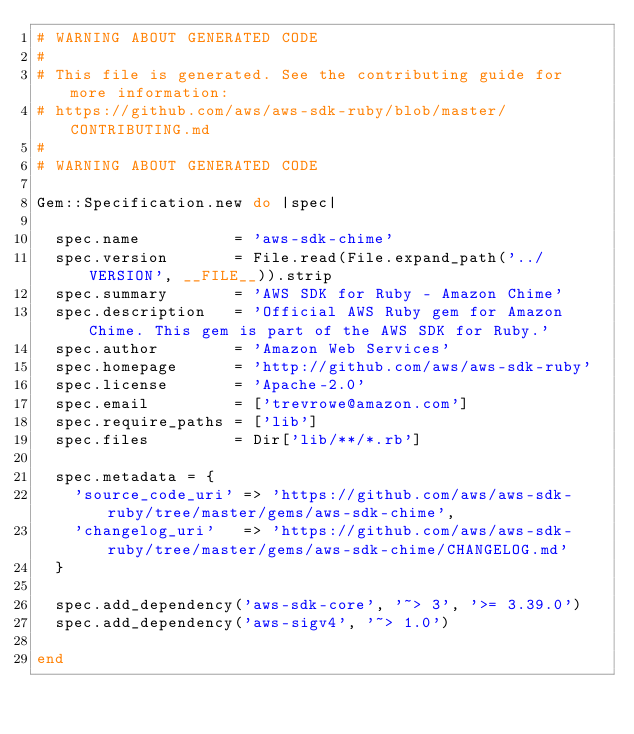Convert code to text. <code><loc_0><loc_0><loc_500><loc_500><_Ruby_># WARNING ABOUT GENERATED CODE
#
# This file is generated. See the contributing guide for more information:
# https://github.com/aws/aws-sdk-ruby/blob/master/CONTRIBUTING.md
#
# WARNING ABOUT GENERATED CODE

Gem::Specification.new do |spec|

  spec.name          = 'aws-sdk-chime'
  spec.version       = File.read(File.expand_path('../VERSION', __FILE__)).strip
  spec.summary       = 'AWS SDK for Ruby - Amazon Chime'
  spec.description   = 'Official AWS Ruby gem for Amazon Chime. This gem is part of the AWS SDK for Ruby.'
  spec.author        = 'Amazon Web Services'
  spec.homepage      = 'http://github.com/aws/aws-sdk-ruby'
  spec.license       = 'Apache-2.0'
  spec.email         = ['trevrowe@amazon.com']
  spec.require_paths = ['lib']
  spec.files         = Dir['lib/**/*.rb']

  spec.metadata = {
    'source_code_uri' => 'https://github.com/aws/aws-sdk-ruby/tree/master/gems/aws-sdk-chime',
    'changelog_uri'   => 'https://github.com/aws/aws-sdk-ruby/tree/master/gems/aws-sdk-chime/CHANGELOG.md'
  }

  spec.add_dependency('aws-sdk-core', '~> 3', '>= 3.39.0')
  spec.add_dependency('aws-sigv4', '~> 1.0')

end
</code> 